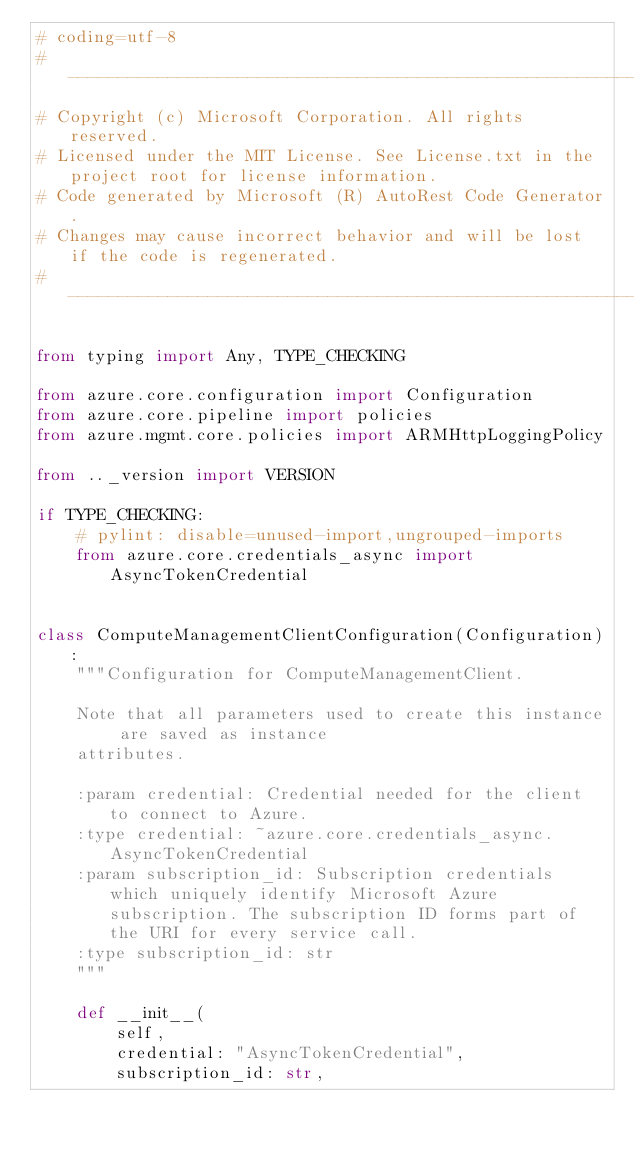<code> <loc_0><loc_0><loc_500><loc_500><_Python_># coding=utf-8
# --------------------------------------------------------------------------
# Copyright (c) Microsoft Corporation. All rights reserved.
# Licensed under the MIT License. See License.txt in the project root for license information.
# Code generated by Microsoft (R) AutoRest Code Generator.
# Changes may cause incorrect behavior and will be lost if the code is regenerated.
# --------------------------------------------------------------------------

from typing import Any, TYPE_CHECKING

from azure.core.configuration import Configuration
from azure.core.pipeline import policies
from azure.mgmt.core.policies import ARMHttpLoggingPolicy

from .._version import VERSION

if TYPE_CHECKING:
    # pylint: disable=unused-import,ungrouped-imports
    from azure.core.credentials_async import AsyncTokenCredential


class ComputeManagementClientConfiguration(Configuration):
    """Configuration for ComputeManagementClient.

    Note that all parameters used to create this instance are saved as instance
    attributes.

    :param credential: Credential needed for the client to connect to Azure.
    :type credential: ~azure.core.credentials_async.AsyncTokenCredential
    :param subscription_id: Subscription credentials which uniquely identify Microsoft Azure subscription. The subscription ID forms part of the URI for every service call.
    :type subscription_id: str
    """

    def __init__(
        self,
        credential: "AsyncTokenCredential",
        subscription_id: str,</code> 